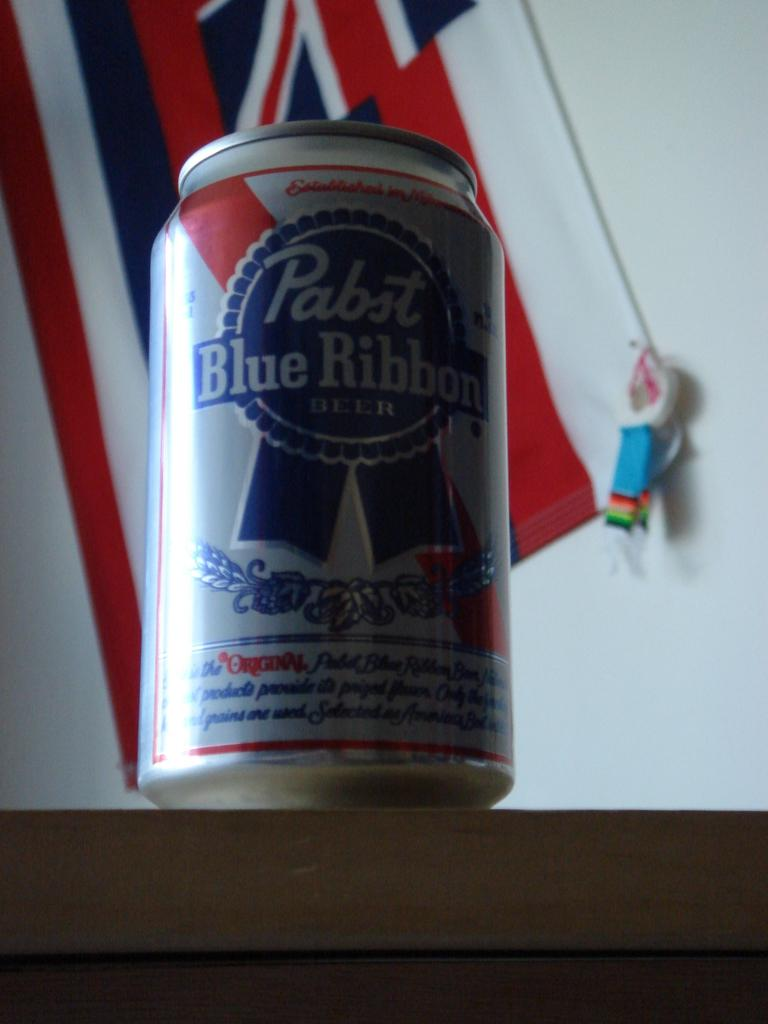<image>
Describe the image concisely. A can of Pabst Blue Ribbon beer sitting on top of a table in front of a flag. 